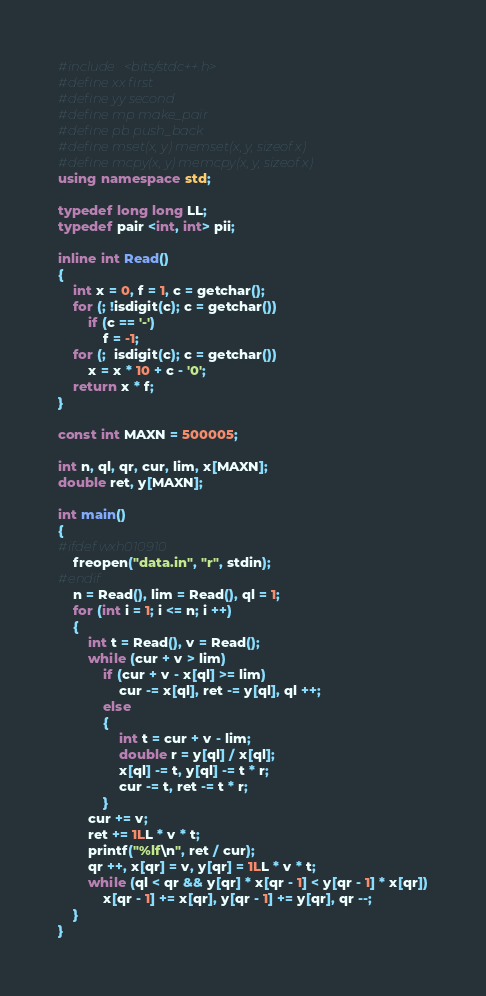Convert code to text. <code><loc_0><loc_0><loc_500><loc_500><_C++_>#include <bits/stdc++.h>
#define xx first
#define yy second
#define mp make_pair
#define pb push_back
#define mset(x, y) memset(x, y, sizeof x)
#define mcpy(x, y) memcpy(x, y, sizeof x)
using namespace std;

typedef long long LL;
typedef pair <int, int> pii;

inline int Read()
{
	int x = 0, f = 1, c = getchar();
	for (; !isdigit(c); c = getchar())
		if (c == '-')
			f = -1;
	for (;  isdigit(c); c = getchar())
		x = x * 10 + c - '0';
	return x * f;
}

const int MAXN = 500005;

int n, ql, qr, cur, lim, x[MAXN];
double ret, y[MAXN];

int main()
{
#ifdef wxh010910
	freopen("data.in", "r", stdin);
#endif
	n = Read(), lim = Read(), ql = 1;
	for (int i = 1; i <= n; i ++)
	{
		int t = Read(), v = Read();
		while (cur + v > lim)
			if (cur + v - x[ql] >= lim)
				cur -= x[ql], ret -= y[ql], ql ++;
			else
			{
				int t = cur + v - lim;
				double r = y[ql] / x[ql];
				x[ql] -= t, y[ql] -= t * r;
				cur -= t, ret -= t * r;
			}
		cur += v;
		ret += 1LL * v * t;
		printf("%lf\n", ret / cur);
		qr ++, x[qr] = v, y[qr] = 1LL * v * t;
		while (ql < qr && y[qr] * x[qr - 1] < y[qr - 1] * x[qr])
			x[qr - 1] += x[qr], y[qr - 1] += y[qr], qr --;
	}
}
</code> 